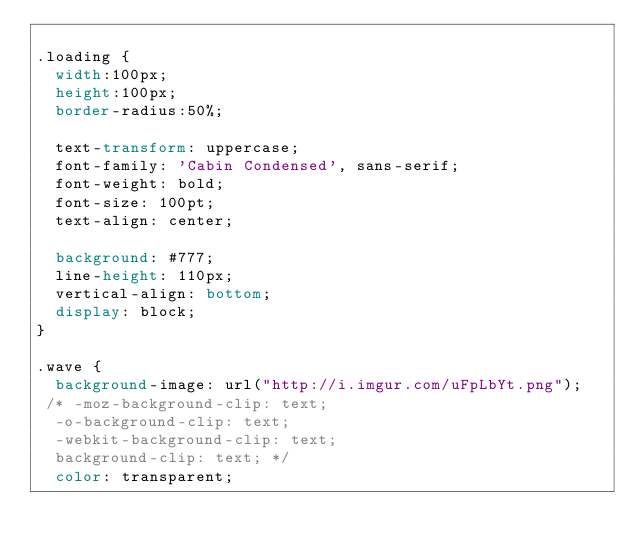<code> <loc_0><loc_0><loc_500><loc_500><_CSS_>
.loading {
	width:100px;
	height:100px;
	border-radius:50%;
	
  text-transform: uppercase;
  font-family: 'Cabin Condensed', sans-serif;
  font-weight: bold;
  font-size: 100pt;
  text-align: center;
  
  background: #777;
  line-height: 110px;
  vertical-align: bottom;
  display: block;
}

.wave {
  background-image: url("http://i.imgur.com/uFpLbYt.png");
 /* -moz-background-clip: text;
  -o-background-clip: text;
  -webkit-background-clip: text;
  background-clip: text; */
  color: transparent;</code> 